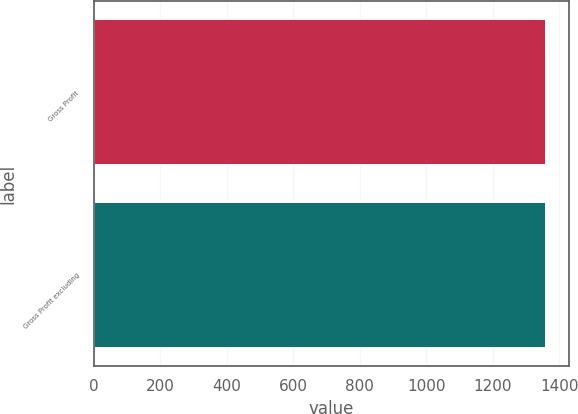<chart> <loc_0><loc_0><loc_500><loc_500><bar_chart><fcel>Gross Profit<fcel>Gross Profit excluding<nl><fcel>1360<fcel>1360.1<nl></chart> 